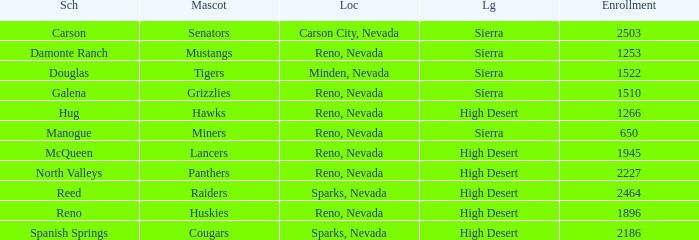Which leagues is the Galena school in? Sierra. 